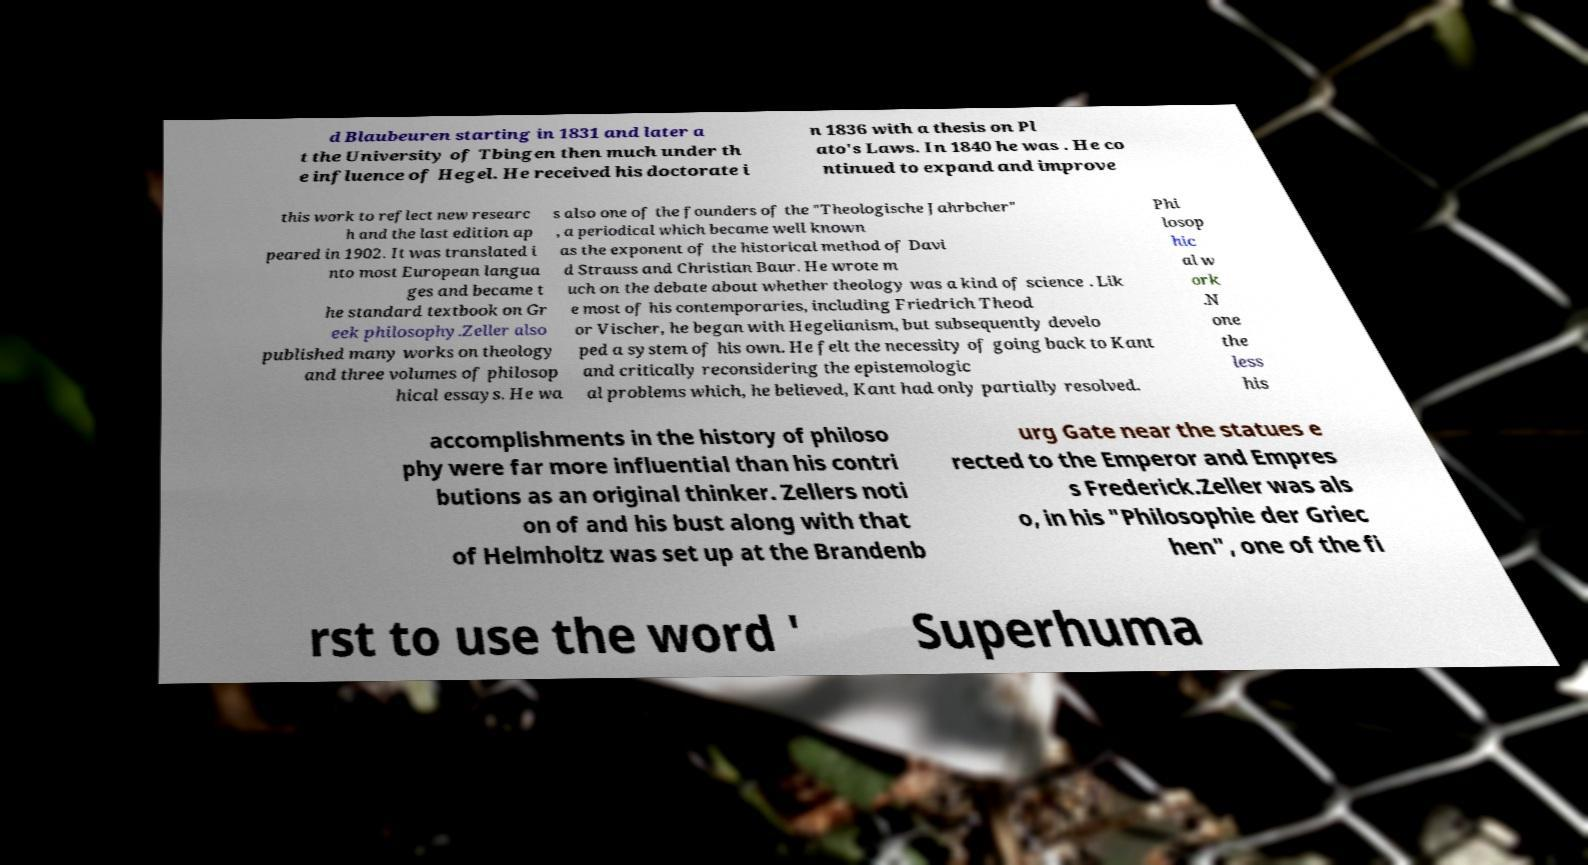Please identify and transcribe the text found in this image. d Blaubeuren starting in 1831 and later a t the University of Tbingen then much under th e influence of Hegel. He received his doctorate i n 1836 with a thesis on Pl ato's Laws. In 1840 he was . He co ntinued to expand and improve this work to reflect new researc h and the last edition ap peared in 1902. It was translated i nto most European langua ges and became t he standard textbook on Gr eek philosophy.Zeller also published many works on theology and three volumes of philosop hical essays. He wa s also one of the founders of the "Theologische Jahrbcher" , a periodical which became well known as the exponent of the historical method of Davi d Strauss and Christian Baur. He wrote m uch on the debate about whether theology was a kind of science . Lik e most of his contemporaries, including Friedrich Theod or Vischer, he began with Hegelianism, but subsequently develo ped a system of his own. He felt the necessity of going back to Kant and critically reconsidering the epistemologic al problems which, he believed, Kant had only partially resolved. Phi losop hic al w ork .N one the less his accomplishments in the history of philoso phy were far more influential than his contri butions as an original thinker. Zellers noti on of and his bust along with that of Helmholtz was set up at the Brandenb urg Gate near the statues e rected to the Emperor and Empres s Frederick.Zeller was als o, in his "Philosophie der Griec hen", one of the fi rst to use the word ' Superhuma 